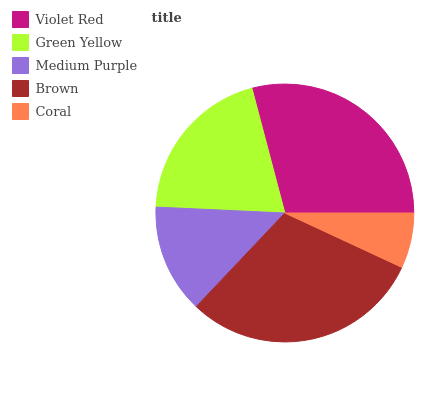Is Coral the minimum?
Answer yes or no. Yes. Is Brown the maximum?
Answer yes or no. Yes. Is Green Yellow the minimum?
Answer yes or no. No. Is Green Yellow the maximum?
Answer yes or no. No. Is Violet Red greater than Green Yellow?
Answer yes or no. Yes. Is Green Yellow less than Violet Red?
Answer yes or no. Yes. Is Green Yellow greater than Violet Red?
Answer yes or no. No. Is Violet Red less than Green Yellow?
Answer yes or no. No. Is Green Yellow the high median?
Answer yes or no. Yes. Is Green Yellow the low median?
Answer yes or no. Yes. Is Coral the high median?
Answer yes or no. No. Is Medium Purple the low median?
Answer yes or no. No. 